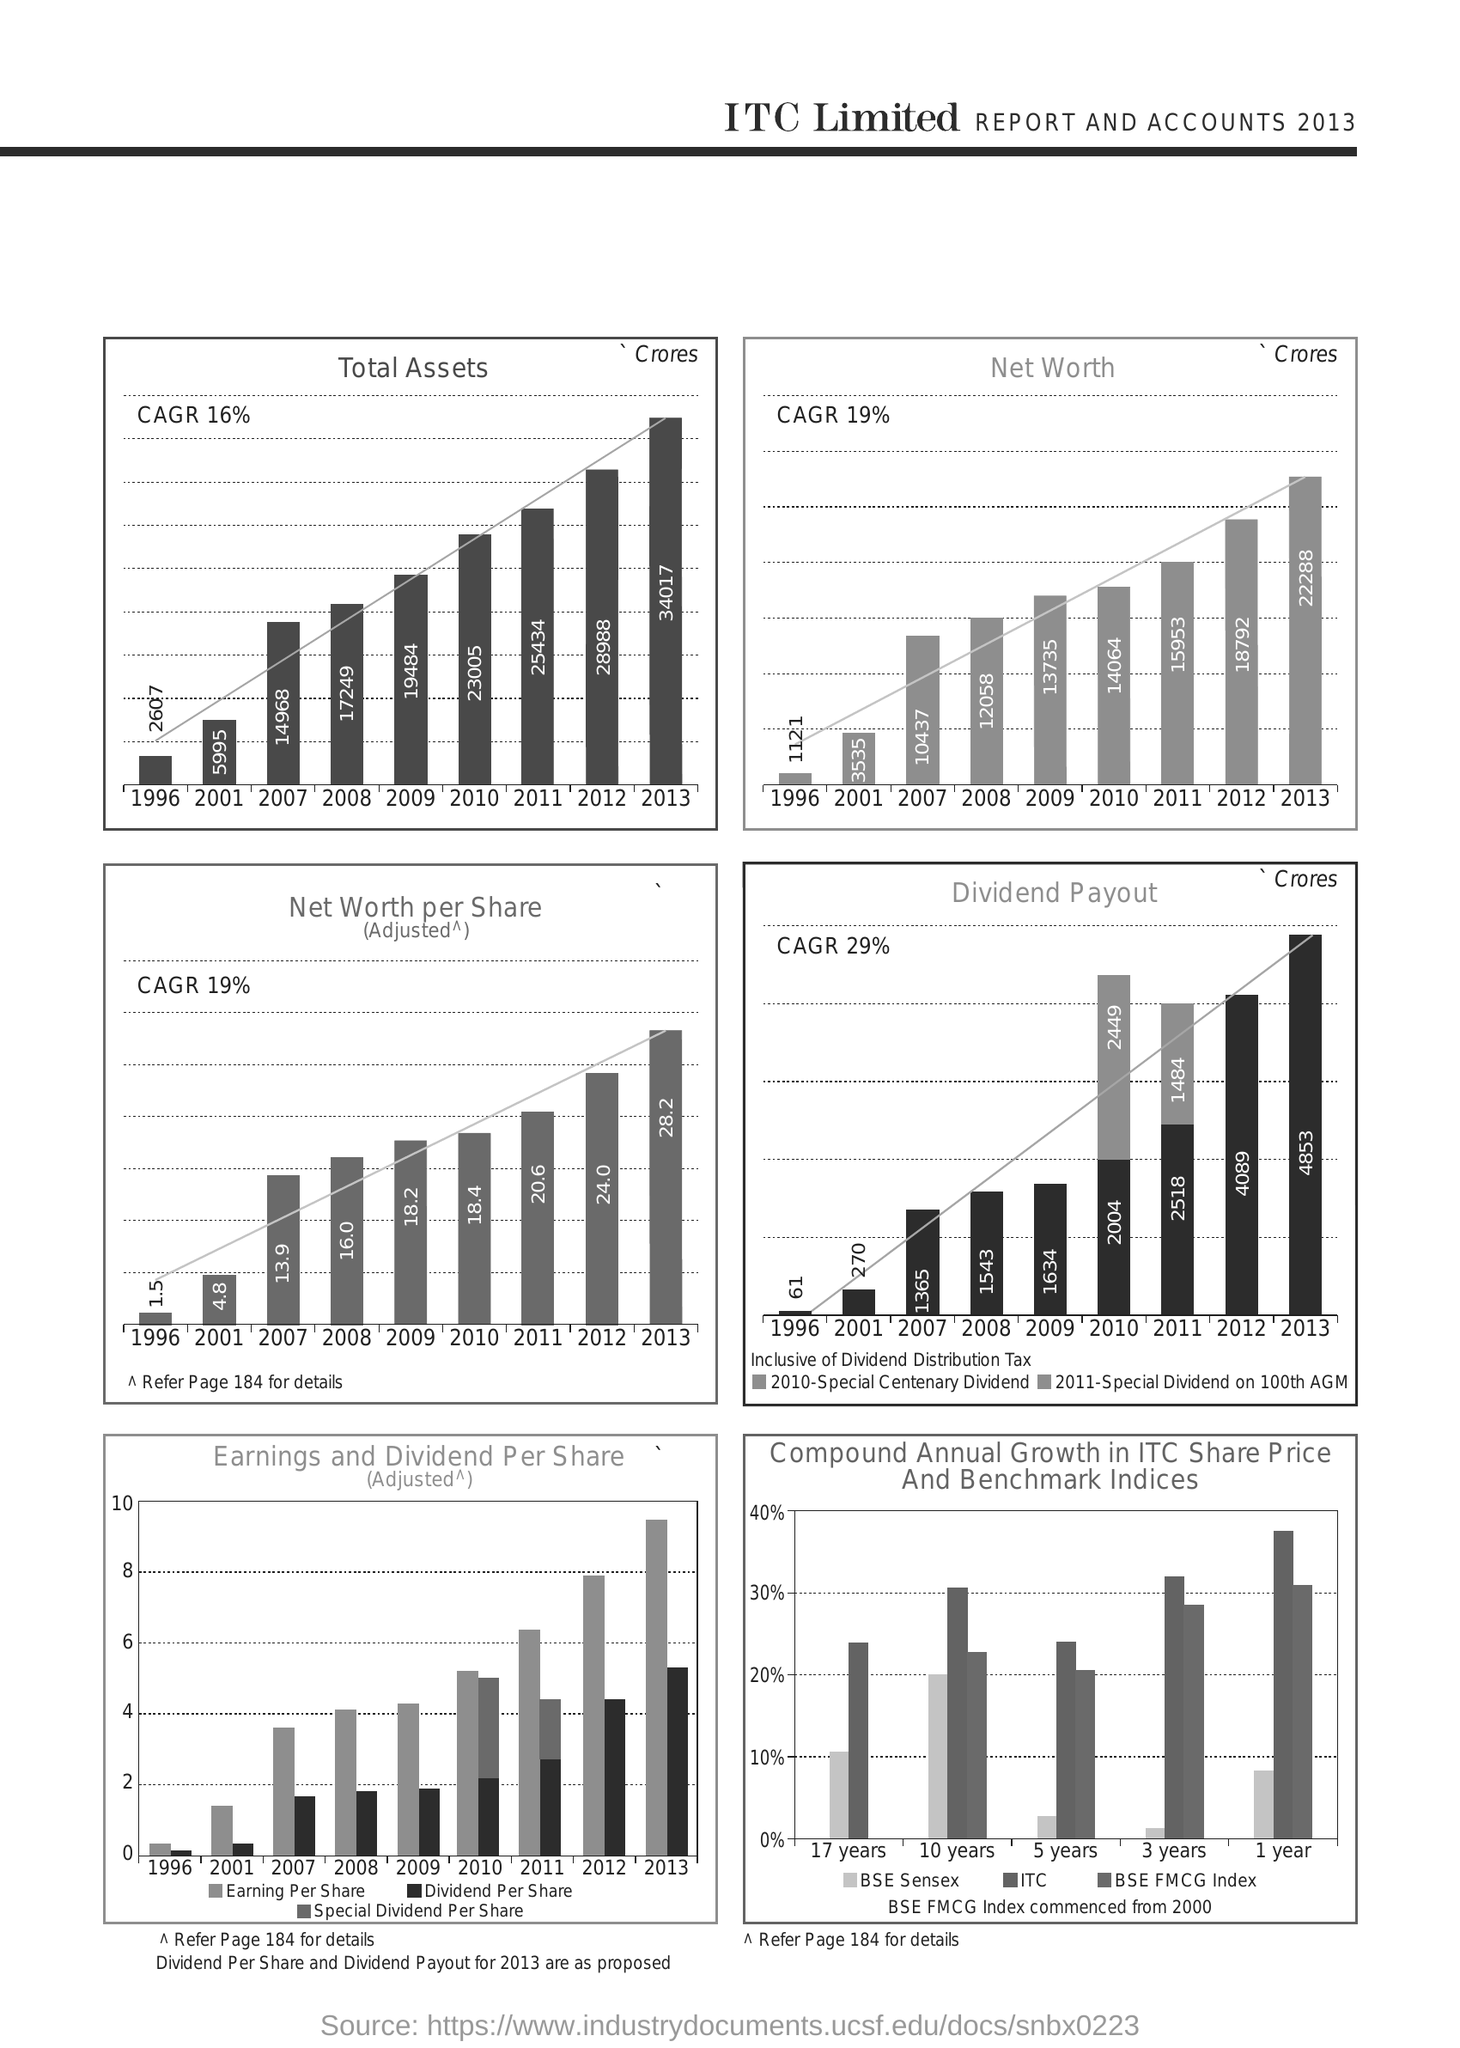Outline some significant characteristics in this image. The graph shows a total assets growth rate of 16% over the given time period. In 2012, the net worth per share was 24.0. The "Dividend Payout" graph shows a CAGR of 29%. In the year 2013, the net worth was 22288 crores. The year with a net worth of 10437 crores is 2007. 